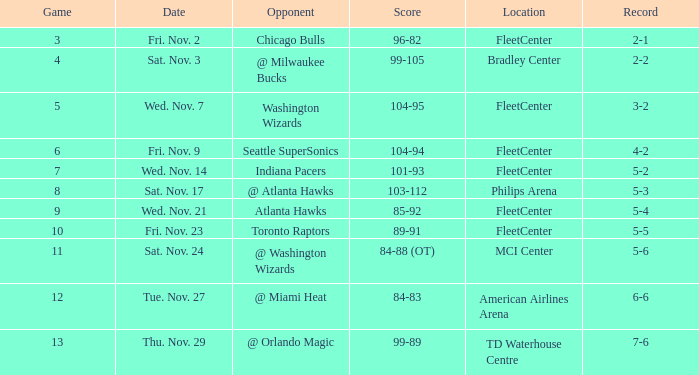How many matches have a score of 85-92? 1.0. 